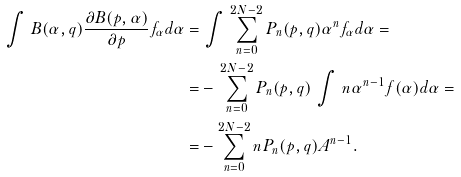<formula> <loc_0><loc_0><loc_500><loc_500>\int \, B ( \alpha , q ) \frac { \partial B ( p , \alpha ) } { \partial p } f _ { \alpha } d \alpha = & \, \int \, \sum _ { n = 0 } ^ { 2 N - 2 } P _ { n } ( p , q ) \alpha ^ { n } f _ { \alpha } d \alpha = \\ = & - \, \sum _ { n = 0 } ^ { 2 N - 2 } P _ { n } ( p , q ) \, \int \, n \alpha ^ { n - 1 } f ( \alpha ) d \alpha = \\ = & - \sum _ { n = 0 } ^ { 2 N - 2 } n P _ { n } ( p , q ) A ^ { n - 1 } .</formula> 